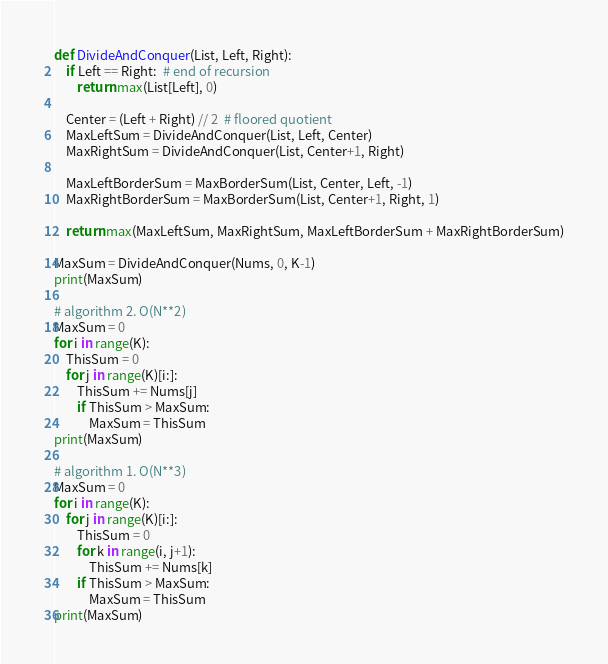<code> <loc_0><loc_0><loc_500><loc_500><_Python_>def DivideAndConquer(List, Left, Right):
    if Left == Right:  # end of recursion
        return max(List[Left], 0)

    Center = (Left + Right) // 2  # floored quotient
    MaxLeftSum = DivideAndConquer(List, Left, Center)
    MaxRightSum = DivideAndConquer(List, Center+1, Right)

    MaxLeftBorderSum = MaxBorderSum(List, Center, Left, -1)
    MaxRightBorderSum = MaxBorderSum(List, Center+1, Right, 1)
    
    return max(MaxLeftSum, MaxRightSum, MaxLeftBorderSum + MaxRightBorderSum)

MaxSum = DivideAndConquer(Nums, 0, K-1)
print(MaxSum)

# algorithm 2. O(N**2)
MaxSum = 0
for i in range(K):
    ThisSum = 0
    for j in range(K)[i:]:
        ThisSum += Nums[j]
        if ThisSum > MaxSum:
            MaxSum = ThisSum
print(MaxSum)

# algorithm 1. O(N**3)
MaxSum = 0
for i in range(K):
    for j in range(K)[i:]:
        ThisSum = 0
        for k in range(i, j+1):
            ThisSum += Nums[k]
        if ThisSum > MaxSum:
            MaxSum = ThisSum
print(MaxSum)
</code> 